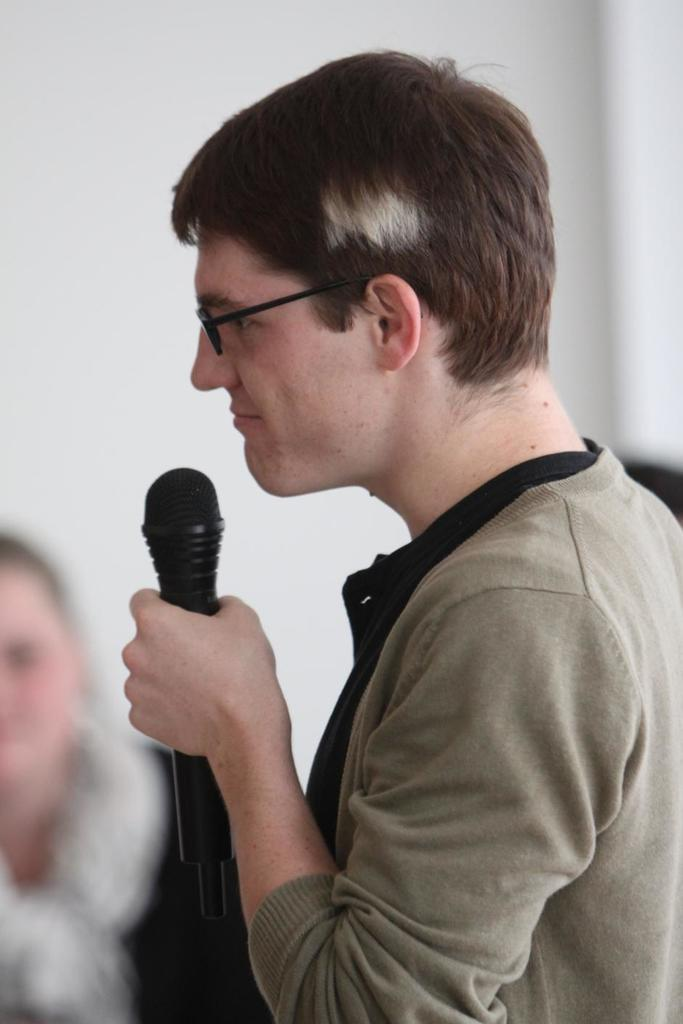What is the main subject of the image? There is a person in the image. What is the person holding in the image? The person is holding a microphone. What type of ray is visible in the image? There is no ray present in the image; it features a person holding a microphone. What message is the person saying good-bye to in the image? The image does not show the person saying good-bye or any specific message. 